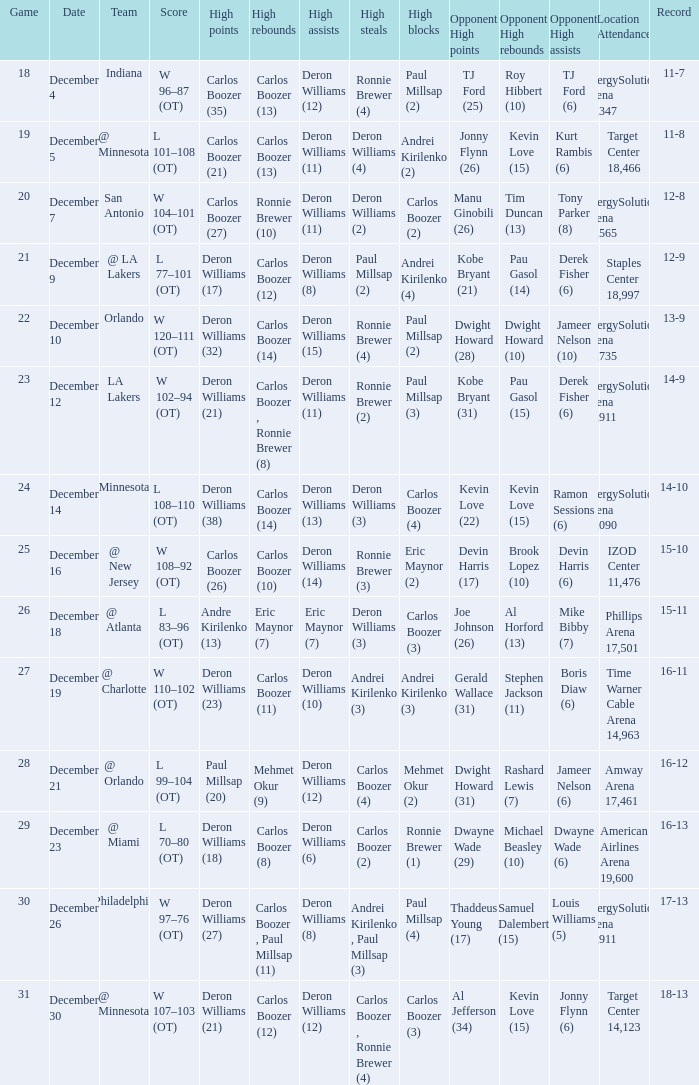When was the game in which Deron Williams (13) did the high assists played? December 14. 